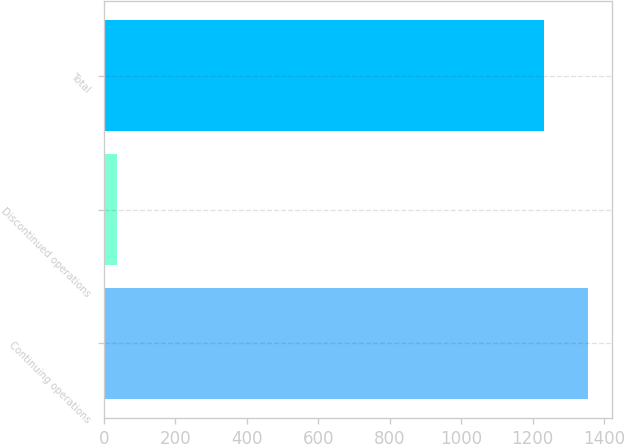Convert chart. <chart><loc_0><loc_0><loc_500><loc_500><bar_chart><fcel>Continuing operations<fcel>Discontinued operations<fcel>Total<nl><fcel>1354.1<fcel>37<fcel>1231<nl></chart> 